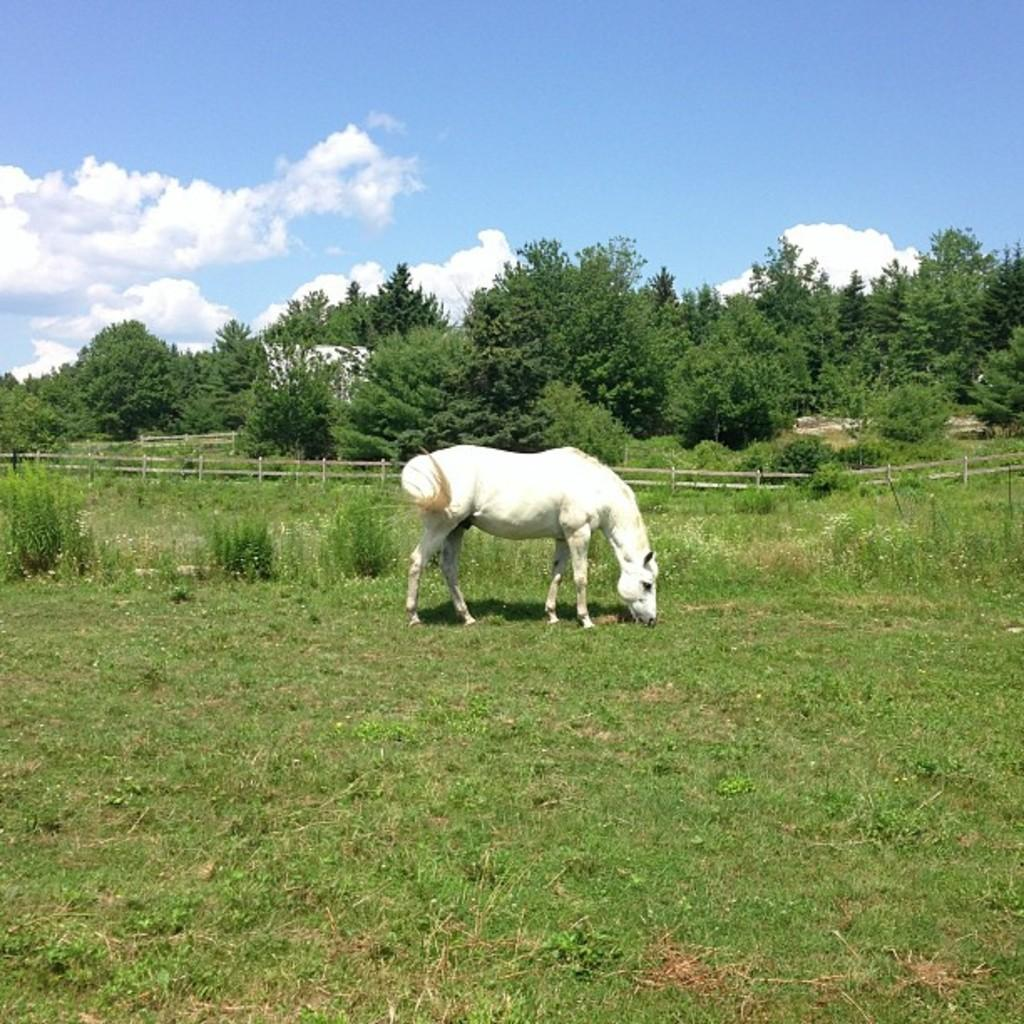Where was the image taken? The image was taken in a field. What can be seen in the foreground of the image? There are shrubs, grass, and a horse in the foreground. What is located in the center of the image? There are trees and fencing in the center of the image. What is visible at the top of the image? The sky is visible at the top of the image. How many accounts does the horse have in the image? There are no accounts mentioned or depicted in the image, as it features a horse in a field. What type of quartz can be seen in the image? There is no quartz present in the image; it features a horse, shrubs, grass, trees, fencing, and a sky. 